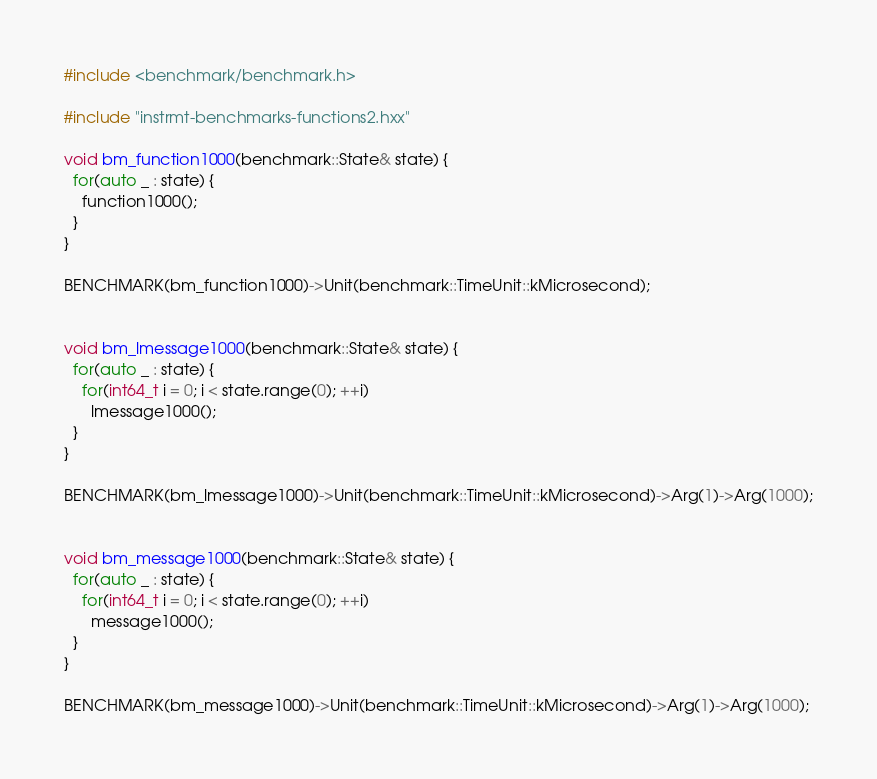<code> <loc_0><loc_0><loc_500><loc_500><_C++_>#include <benchmark/benchmark.h>

#include "instrmt-benchmarks-functions2.hxx"

void bm_function1000(benchmark::State& state) {
  for(auto _ : state) {
    function1000();
  }
}

BENCHMARK(bm_function1000)->Unit(benchmark::TimeUnit::kMicrosecond);


void bm_lmessage1000(benchmark::State& state) {
  for(auto _ : state) {
    for(int64_t i = 0; i < state.range(0); ++i)
      lmessage1000();
  }
}

BENCHMARK(bm_lmessage1000)->Unit(benchmark::TimeUnit::kMicrosecond)->Arg(1)->Arg(1000);


void bm_message1000(benchmark::State& state) {
  for(auto _ : state) {
    for(int64_t i = 0; i < state.range(0); ++i)
      message1000();
  }
}

BENCHMARK(bm_message1000)->Unit(benchmark::TimeUnit::kMicrosecond)->Arg(1)->Arg(1000);
</code> 